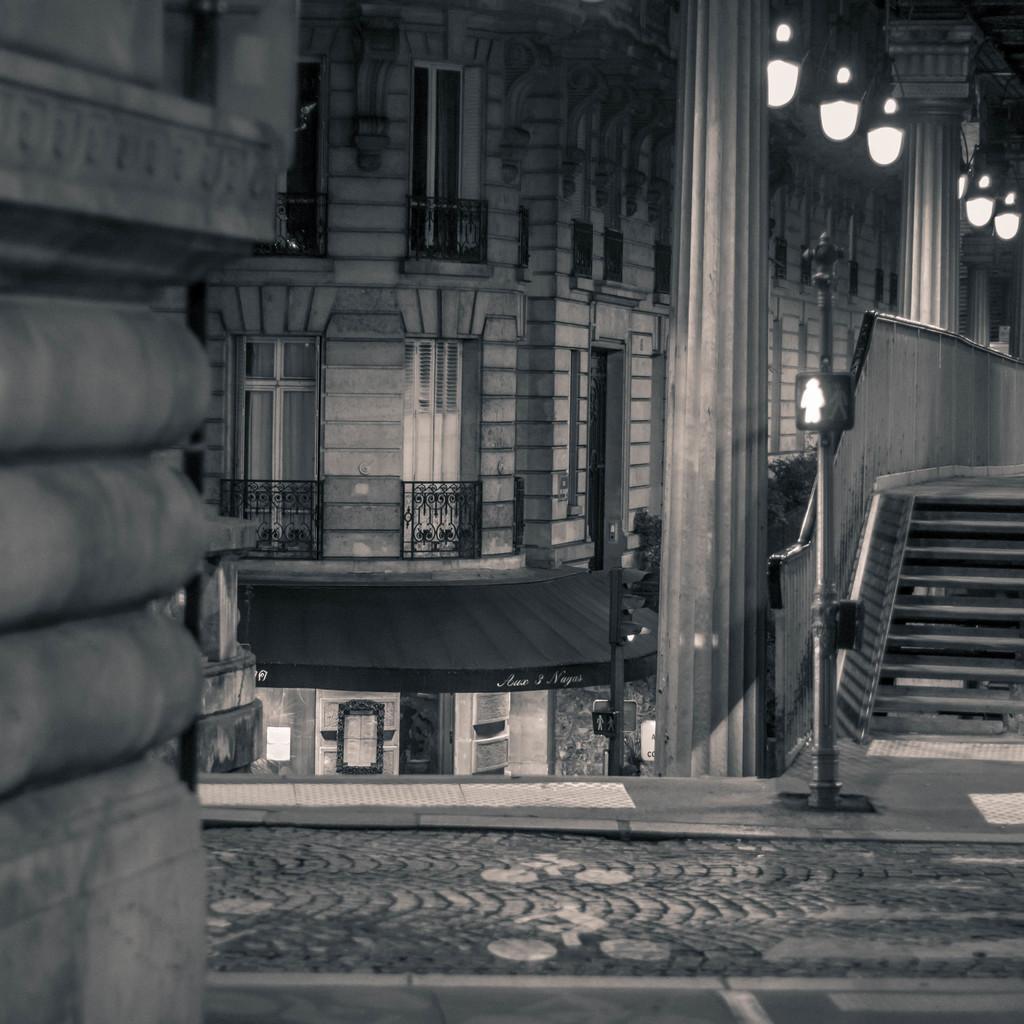In one or two sentences, can you explain what this image depicts? In this picture we can see a building, where we can see lights, poles and some objects. 